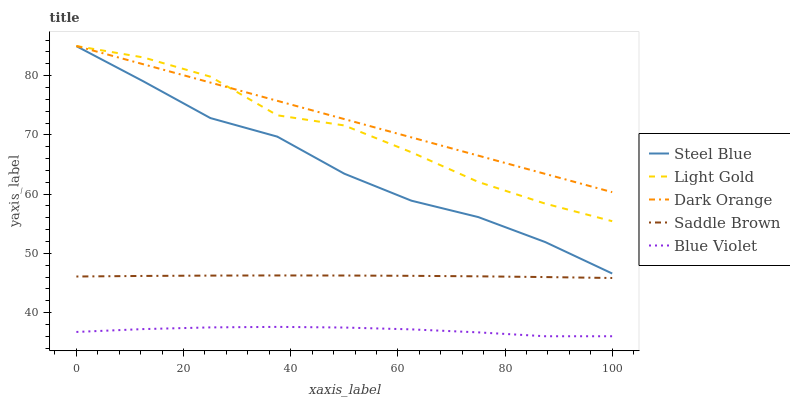Does Blue Violet have the minimum area under the curve?
Answer yes or no. Yes. Does Dark Orange have the maximum area under the curve?
Answer yes or no. Yes. Does Light Gold have the minimum area under the curve?
Answer yes or no. No. Does Light Gold have the maximum area under the curve?
Answer yes or no. No. Is Dark Orange the smoothest?
Answer yes or no. Yes. Is Light Gold the roughest?
Answer yes or no. Yes. Is Steel Blue the smoothest?
Answer yes or no. No. Is Steel Blue the roughest?
Answer yes or no. No. Does Blue Violet have the lowest value?
Answer yes or no. Yes. Does Light Gold have the lowest value?
Answer yes or no. No. Does Light Gold have the highest value?
Answer yes or no. Yes. Does Steel Blue have the highest value?
Answer yes or no. No. Is Saddle Brown less than Dark Orange?
Answer yes or no. Yes. Is Light Gold greater than Saddle Brown?
Answer yes or no. Yes. Does Light Gold intersect Dark Orange?
Answer yes or no. Yes. Is Light Gold less than Dark Orange?
Answer yes or no. No. Is Light Gold greater than Dark Orange?
Answer yes or no. No. Does Saddle Brown intersect Dark Orange?
Answer yes or no. No. 